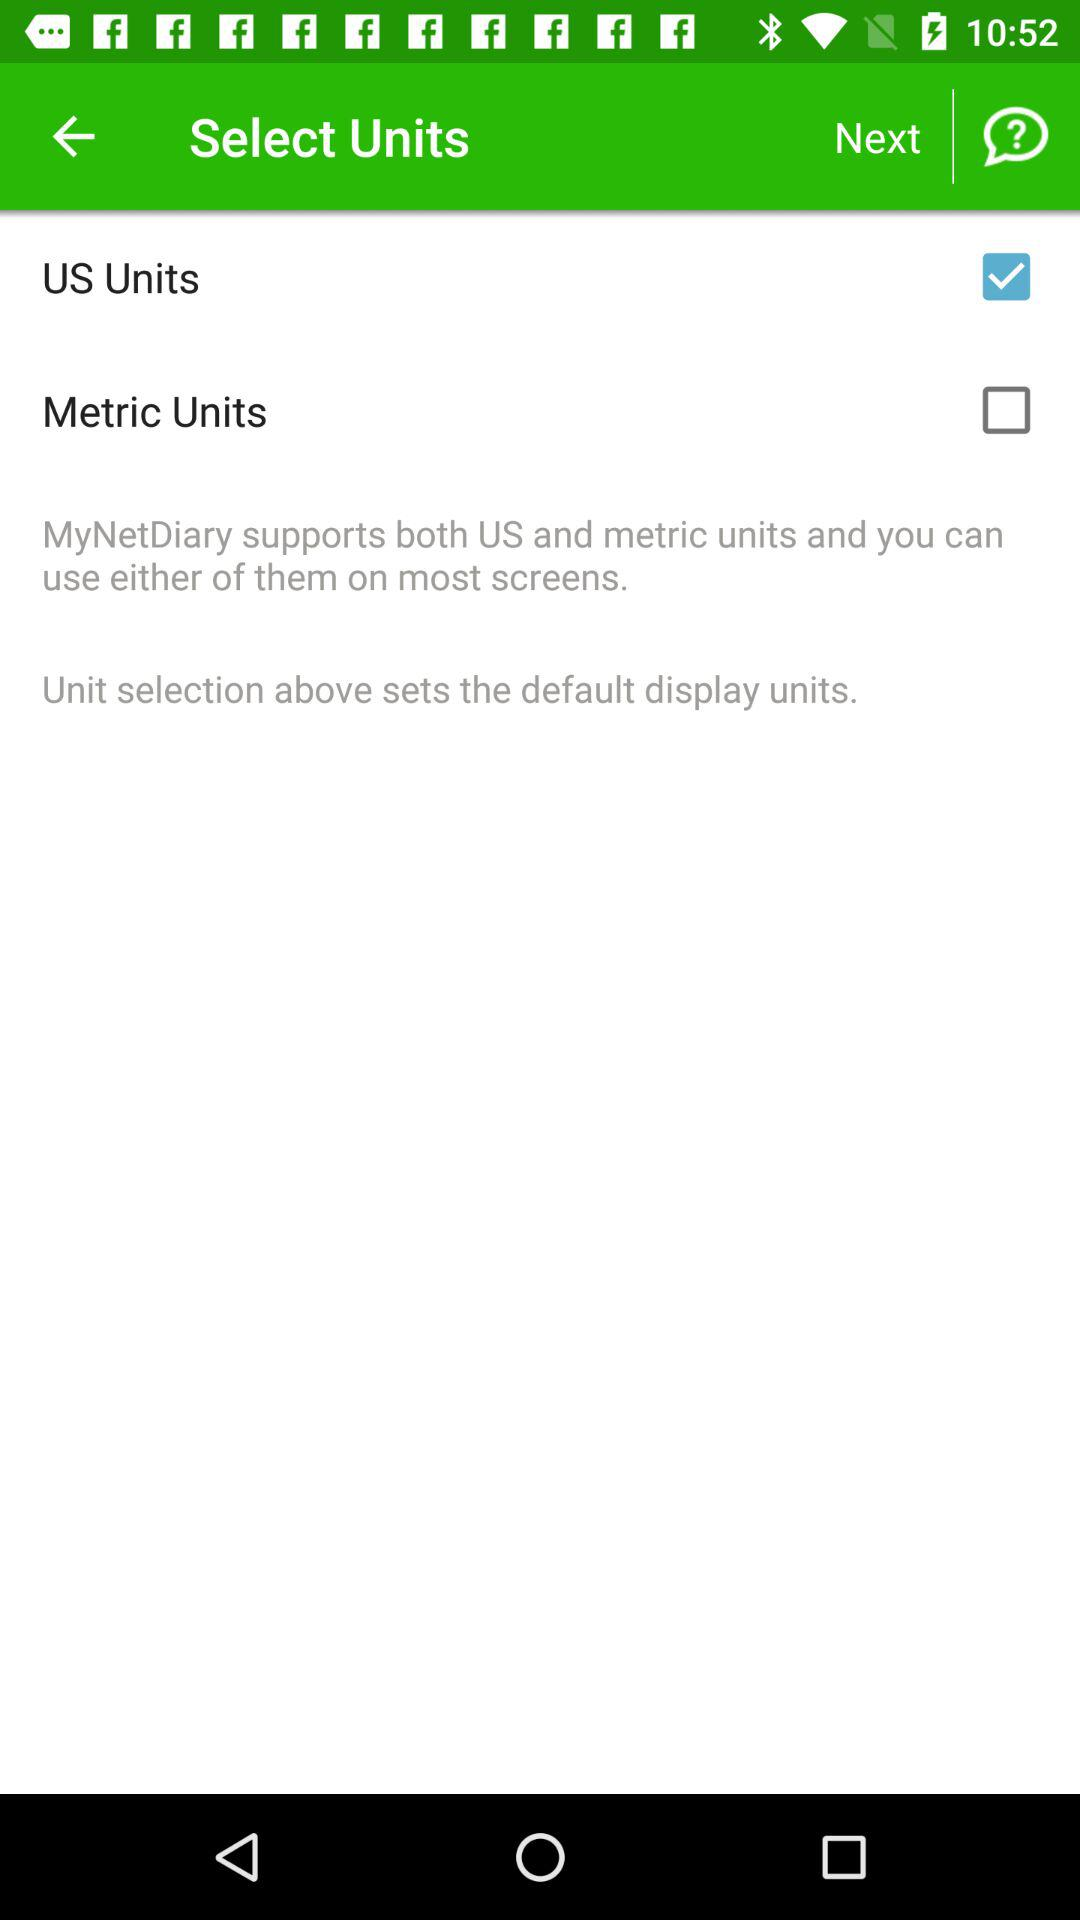Which is the selected unit? The selected unit is "US Units". 